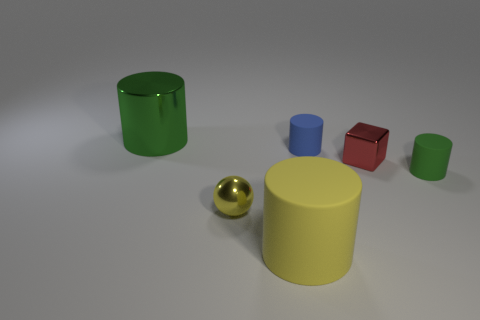Add 4 yellow rubber cylinders. How many objects exist? 10 Add 6 small yellow spheres. How many small yellow spheres are left? 7 Add 4 tiny blue matte objects. How many tiny blue matte objects exist? 5 Subtract all green cylinders. How many cylinders are left? 2 Subtract all matte cylinders. How many cylinders are left? 1 Subtract 0 blue spheres. How many objects are left? 6 Subtract all cubes. How many objects are left? 5 Subtract 1 cubes. How many cubes are left? 0 Subtract all green cylinders. Subtract all green blocks. How many cylinders are left? 2 Subtract all red blocks. How many green cylinders are left? 2 